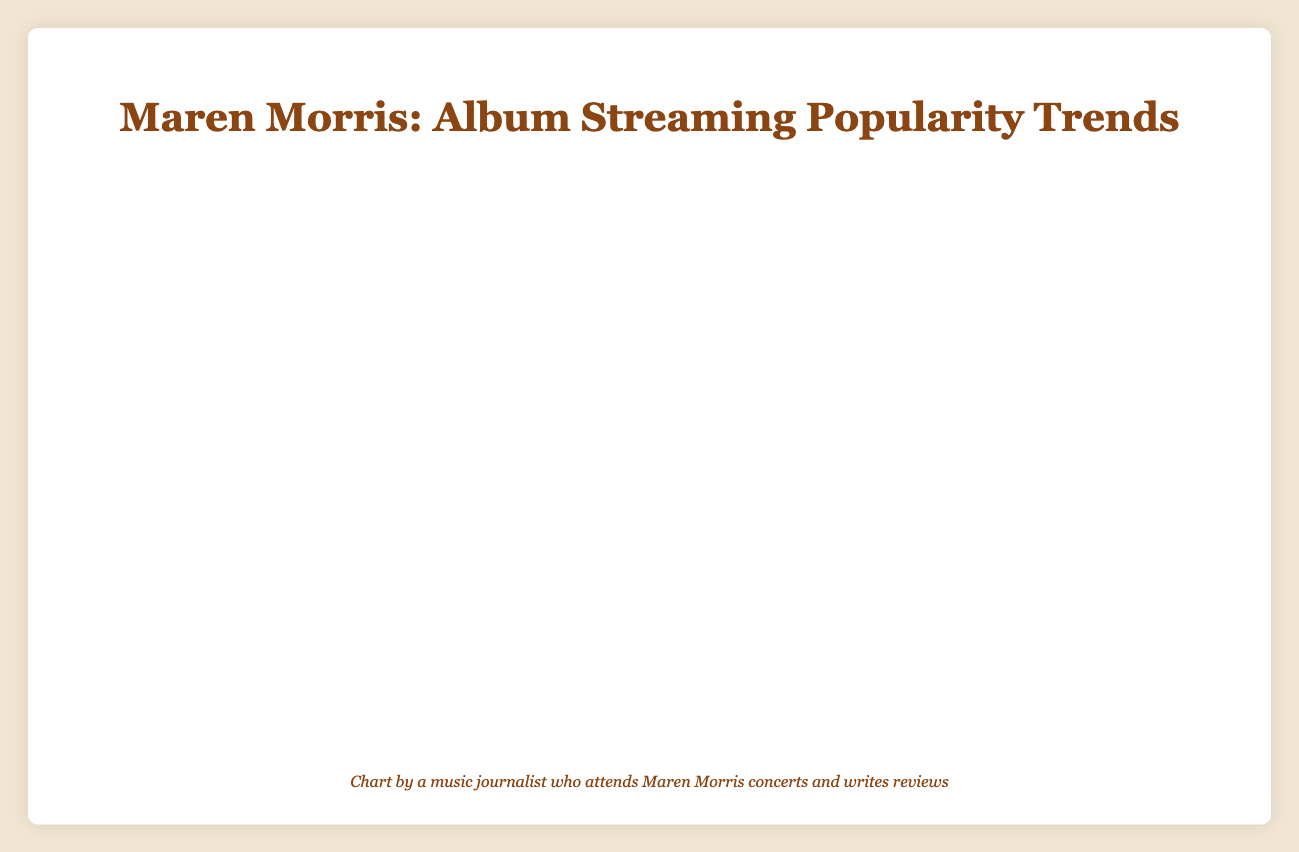What is the highest number of monthly listeners for the album "Humble Quest"? According to the plot, the highest number of monthly listeners for "Humble Quest" can be seen in February 2023, where it reaches 1,010,000 listeners.
Answer: 1,010,000 How does the streaming trend of "Girl" one year after its release compare to the initial release month? "Girl" was released in March 2019 with 650,000 listeners. By February 2020, it reached 820,000 listeners. To compare, 820,000 - 650,000 = 170,000, showing an increase of 170,000 listeners.
Answer: An increase of 170,000 listeners Which album had a more rapid increase in listeners in the first 6 months after release, "Hero" or "Girl"? "Hero" increased from 450,000 to 540,000 listeners in the first 6 months (difference of 90,000), while "Girl" increased from 650,000 to 740,000 listeners in the same period (difference of 90,000). Both had an equal increase of 90,000 listeners.
Answer: Both had an equal increase of 90,000 listeners After one year, which album had the most listeners, "Hero" or "Girl"? "Hero" had 620,000 listeners by May 2017, one year after its release. "Girl" had 820,000 listeners by February 2020, one year after its release. Therefore, "Girl" had more listeners compared to "Hero" after one year.
Answer: "Girl" What is the general trend seen in the number of listeners for Maren Morris' albums post-release? By examining the plot, it is evident that all three albums ("Hero," "Girl," and "Humble Quest") exhibit an increasing trend in the number of listeners over time post-release.
Answer: Increasing trend Comparing the listener growth rate between "Hero" and "Humble Quest", which one shows a steeper climb? "Humble Quest" shows a steeper climb, going from 850,000 listeners in March 2022 to 1,010,000 listeners in February 2023 (an increase of 160,000 in 12 months). In contrast, "Hero" increased from 450,000 in June 2016 to 620,000 by May 2017 (an increase of 170,000 in 12 months). Although the numerical increase is similar, the initial listener base for "Humble Quest" was much higher, indicating a steeper climb.
Answer: "Humble Quest" Which album maintained a consistent growth in listeners without any dips? By observing the plot, "Humble Quest" shows consistent growth in its listeners from March 2022 to February 2023 without any dips.
Answer: "Humble Quest" What's the combined number of listeners for "Hero" and "Girl" in December 2019? For December 2019, "Hero" and "Girl" had 540,000 and 790,000 listeners respectively. Combined, their listeners total 540,000 + 790,000 = 1,330,000 listeners.
Answer: 1,330,000 listeners Which album had the highest first-month listener count upon release? By checking the figure, "Humble Quest" had the highest first-month listener count with 850,000 listeners in March 2022.
Answer: "Humble Quest" 